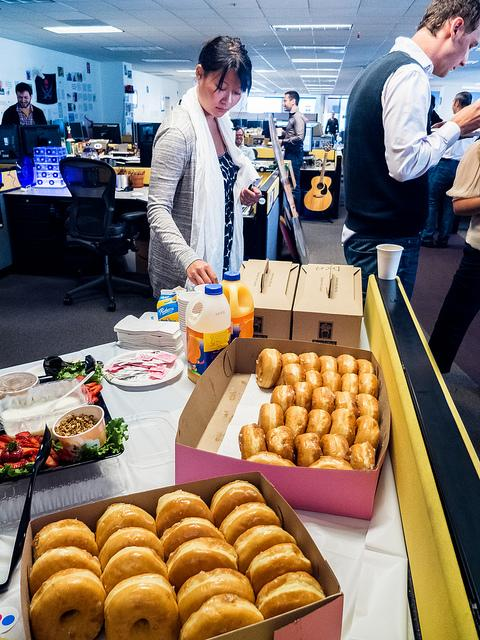What setting does this seem to be?

Choices:
A) school
B) office
C) library
D) home office 